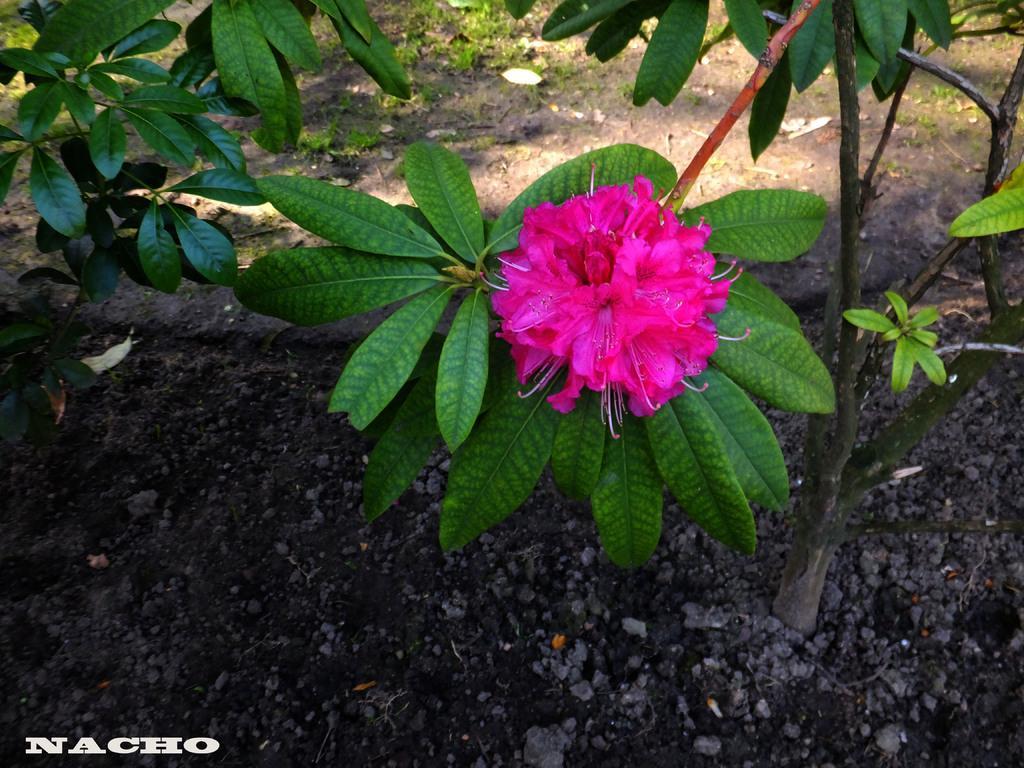In one or two sentences, can you explain what this image depicts? In the picture I can see pink color flowers of a plant, I can see stones and grass on the ground. Here I can see a few more plants and here I can see the watermark at the bottom left side of the image. 